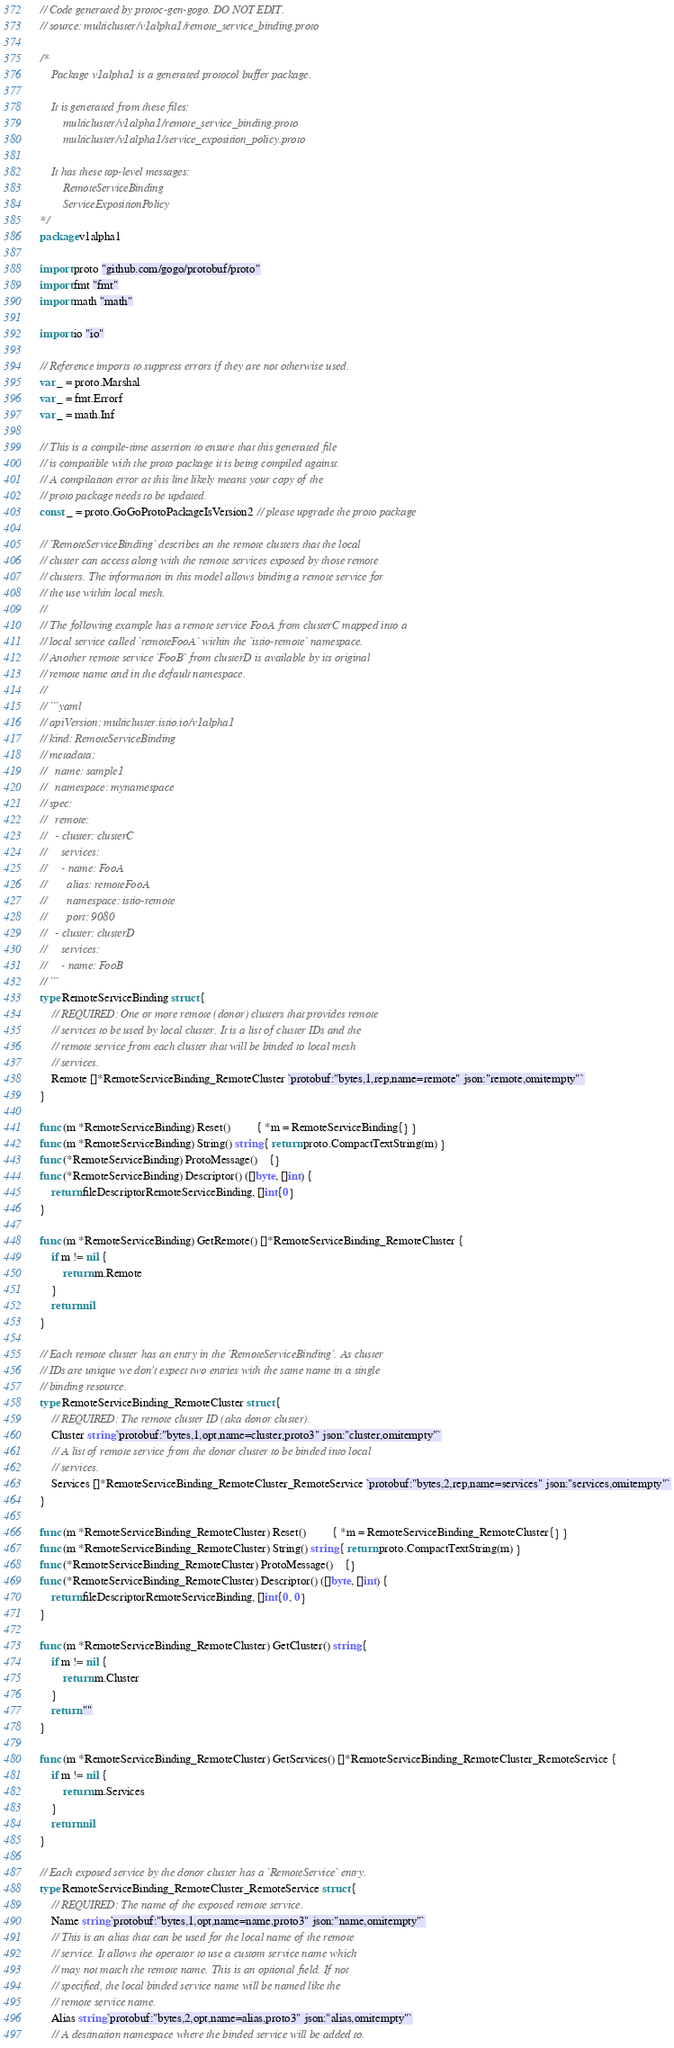<code> <loc_0><loc_0><loc_500><loc_500><_Go_>// Code generated by protoc-gen-gogo. DO NOT EDIT.
// source: multicluster/v1alpha1/remote_service_binding.proto

/*
	Package v1alpha1 is a generated protocol buffer package.

	It is generated from these files:
		multicluster/v1alpha1/remote_service_binding.proto
		multicluster/v1alpha1/service_exposition_policy.proto

	It has these top-level messages:
		RemoteServiceBinding
		ServiceExpositionPolicy
*/
package v1alpha1

import proto "github.com/gogo/protobuf/proto"
import fmt "fmt"
import math "math"

import io "io"

// Reference imports to suppress errors if they are not otherwise used.
var _ = proto.Marshal
var _ = fmt.Errorf
var _ = math.Inf

// This is a compile-time assertion to ensure that this generated file
// is compatible with the proto package it is being compiled against.
// A compilation error at this line likely means your copy of the
// proto package needs to be updated.
const _ = proto.GoGoProtoPackageIsVersion2 // please upgrade the proto package

// `RemoteServiceBinding` describes an the remote clusters that the local
// cluster can access along with the remote services exposed by those remote
// clusters. The information in this model allows binding a remote service for
// the use within local mesh.
//
// The following example has a remote service FooA from clusterC mapped into a
// local service called `remoteFooA` within the `istio-remote` namespace.
// Another remote service `FooB` from clusterD is available by its original
// remote name and in the default namespace.
//
// ```yaml
// apiVersion: multicluster.istio.io/v1alpha1
// kind: RemoteServiceBinding
// metadata:
//   name: sample1
//   namespace: mynamespace
// spec:
//   remote:
//   - cluster: clusterC
//     services:
//     - name: FooA
//       alias: remoteFooA
//       namespace: istio-remote
//       port: 9080
//   - cluster: clusterD
//     services:
//     - name: FooB
// ```
type RemoteServiceBinding struct {
	// REQUIRED: One or more remote (donor) clusters that provides remote
	// services to be used by local cluster. It is a list of cluster IDs and the
	// remote service from each cluster that will be binded to local mesh
	// services.
	Remote []*RemoteServiceBinding_RemoteCluster `protobuf:"bytes,1,rep,name=remote" json:"remote,omitempty"`
}

func (m *RemoteServiceBinding) Reset()         { *m = RemoteServiceBinding{} }
func (m *RemoteServiceBinding) String() string { return proto.CompactTextString(m) }
func (*RemoteServiceBinding) ProtoMessage()    {}
func (*RemoteServiceBinding) Descriptor() ([]byte, []int) {
	return fileDescriptorRemoteServiceBinding, []int{0}
}

func (m *RemoteServiceBinding) GetRemote() []*RemoteServiceBinding_RemoteCluster {
	if m != nil {
		return m.Remote
	}
	return nil
}

// Each remote cluster has an entry in the `RemoteServiceBinding`. As cluster
// IDs are unique we don't expect two entries with the same name in a single
// binding resource.
type RemoteServiceBinding_RemoteCluster struct {
	// REQUIRED: The remote cluster ID (aka donor cluster).
	Cluster string `protobuf:"bytes,1,opt,name=cluster,proto3" json:"cluster,omitempty"`
	// A list of remote service from the donor cluster to be binded into local
	// services.
	Services []*RemoteServiceBinding_RemoteCluster_RemoteService `protobuf:"bytes,2,rep,name=services" json:"services,omitempty"`
}

func (m *RemoteServiceBinding_RemoteCluster) Reset()         { *m = RemoteServiceBinding_RemoteCluster{} }
func (m *RemoteServiceBinding_RemoteCluster) String() string { return proto.CompactTextString(m) }
func (*RemoteServiceBinding_RemoteCluster) ProtoMessage()    {}
func (*RemoteServiceBinding_RemoteCluster) Descriptor() ([]byte, []int) {
	return fileDescriptorRemoteServiceBinding, []int{0, 0}
}

func (m *RemoteServiceBinding_RemoteCluster) GetCluster() string {
	if m != nil {
		return m.Cluster
	}
	return ""
}

func (m *RemoteServiceBinding_RemoteCluster) GetServices() []*RemoteServiceBinding_RemoteCluster_RemoteService {
	if m != nil {
		return m.Services
	}
	return nil
}

// Each exposed service by the donor cluster has a `RemoteService` entry.
type RemoteServiceBinding_RemoteCluster_RemoteService struct {
	// REQUIRED: The name of the exposed remote service.
	Name string `protobuf:"bytes,1,opt,name=name,proto3" json:"name,omitempty"`
	// This is an alias that can be used for the local name of the remote
	// service. It allows the operator to use a custom service name which
	// may not match the remote name. This is an optional field. If not
	// specified, the local binded service name will be named like the
	// remote service name.
	Alias string `protobuf:"bytes,2,opt,name=alias,proto3" json:"alias,omitempty"`
	// A destination namespace where the binded service will be added to.</code> 